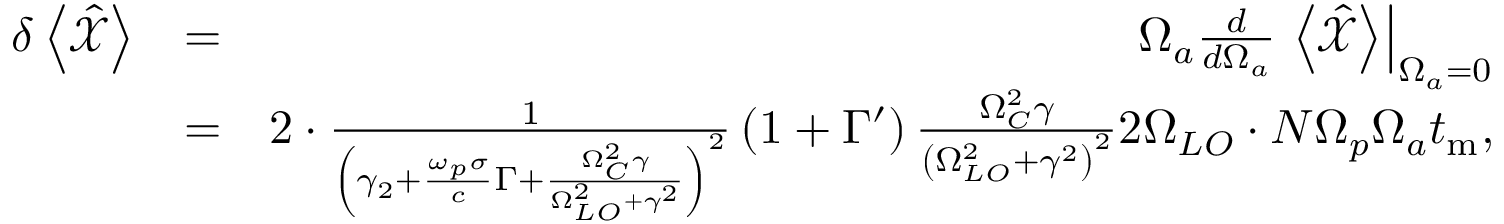<formula> <loc_0><loc_0><loc_500><loc_500>\begin{array} { r l r } { \delta \left < \hat { \mathcal { X } } \right > } & { = } & { \Omega _ { a } \frac { d } { d \Omega _ { a } } \left < \hat { \mathcal { X } } \right > \right | _ { \Omega _ { a } = 0 } } \\ & { = } & { 2 \cdot \frac { 1 } { \left ( \gamma _ { 2 } + \frac { \omega _ { p } \sigma } { c } \Gamma + \frac { \Omega _ { C } ^ { 2 } \gamma } { \Omega _ { L O } ^ { 2 } + \gamma ^ { 2 } } \right ) ^ { 2 } } \left ( 1 + \Gamma ^ { \prime } \right ) \frac { \Omega _ { C } ^ { 2 } \gamma } { \left ( \Omega _ { L O } ^ { 2 } + \gamma ^ { 2 } \right ) ^ { 2 } } 2 \Omega _ { L O } \cdot N \Omega _ { p } \Omega _ { a } t _ { m } , } \end{array}</formula> 